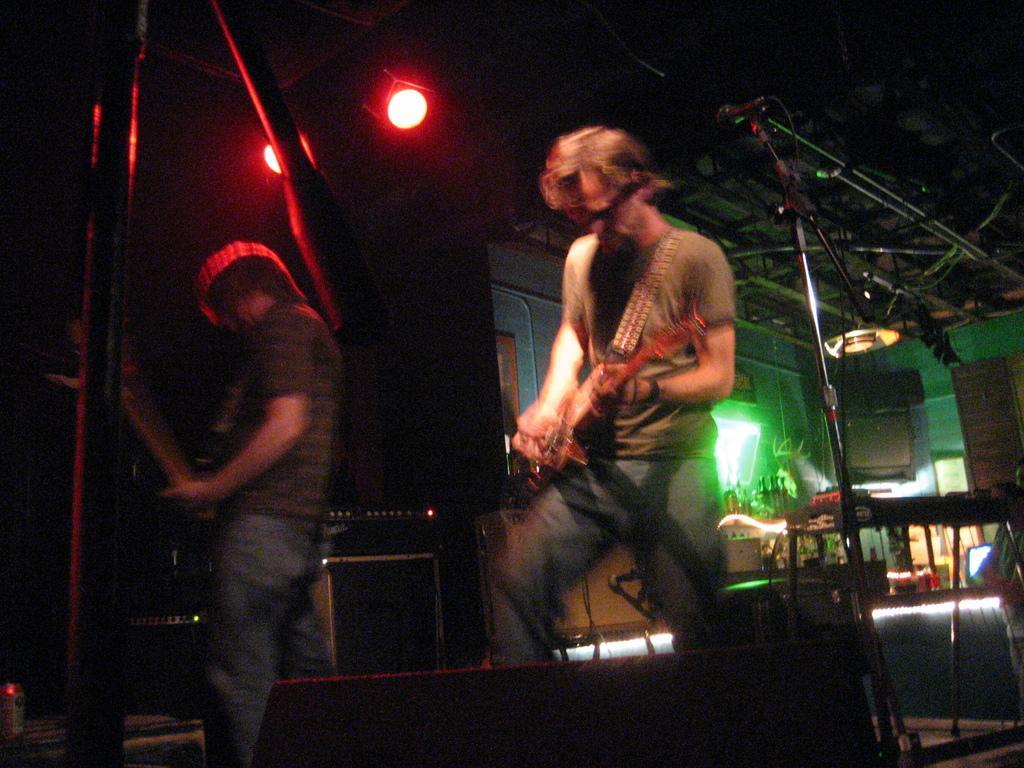Please provide a concise description of this image. In this image i can see two man standing and playing a musical instrument at the background i can see a micro phone, a wall and a light. 